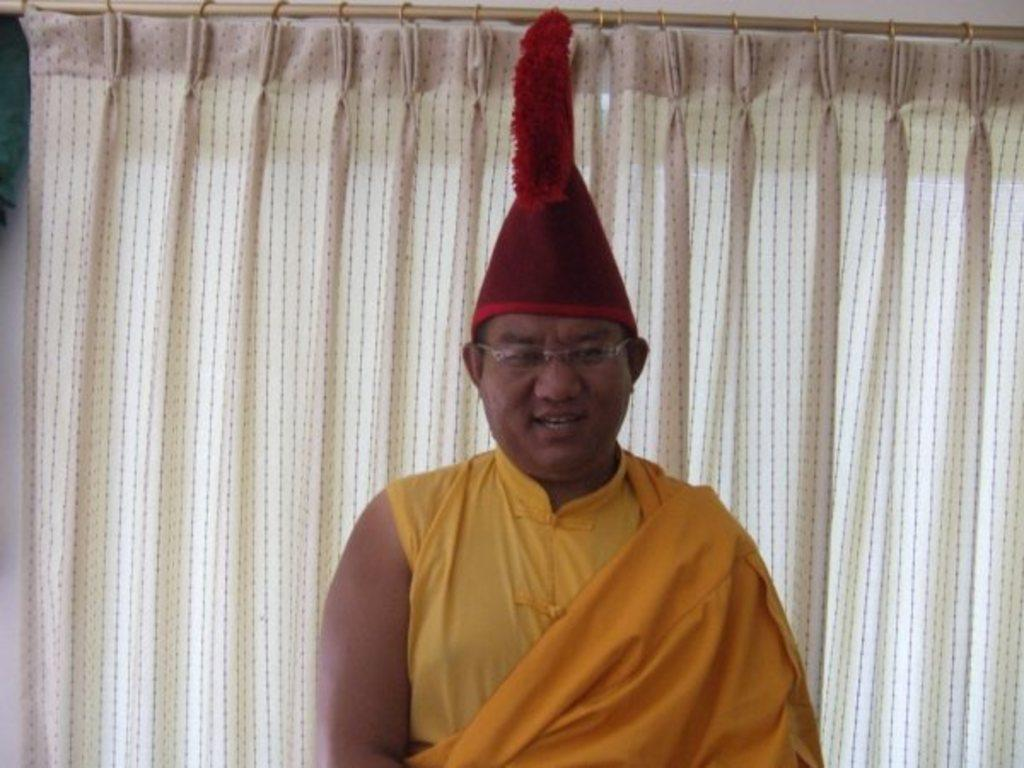What is the main subject of the image? There is a person in the image. What is the person wearing on their head? The person is wearing a red cap. What type of eyewear is the person wearing? The person is wearing spectacles. What color is the dress the person is wearing? The person is wearing a yellow dress. What can be seen in the background of the image? There is a curtain in the background of the image. How many houses can be seen in the image? There are no houses visible in the image; it features a person wearing a red cap and a yellow dress. What type of birds are flying in the image? There are no birds present in the image. 